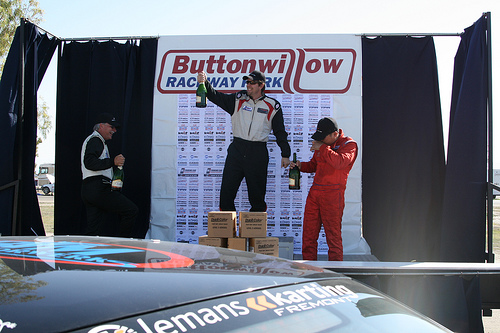<image>
Can you confirm if the box is on the car? No. The box is not positioned on the car. They may be near each other, but the box is not supported by or resting on top of the car. 